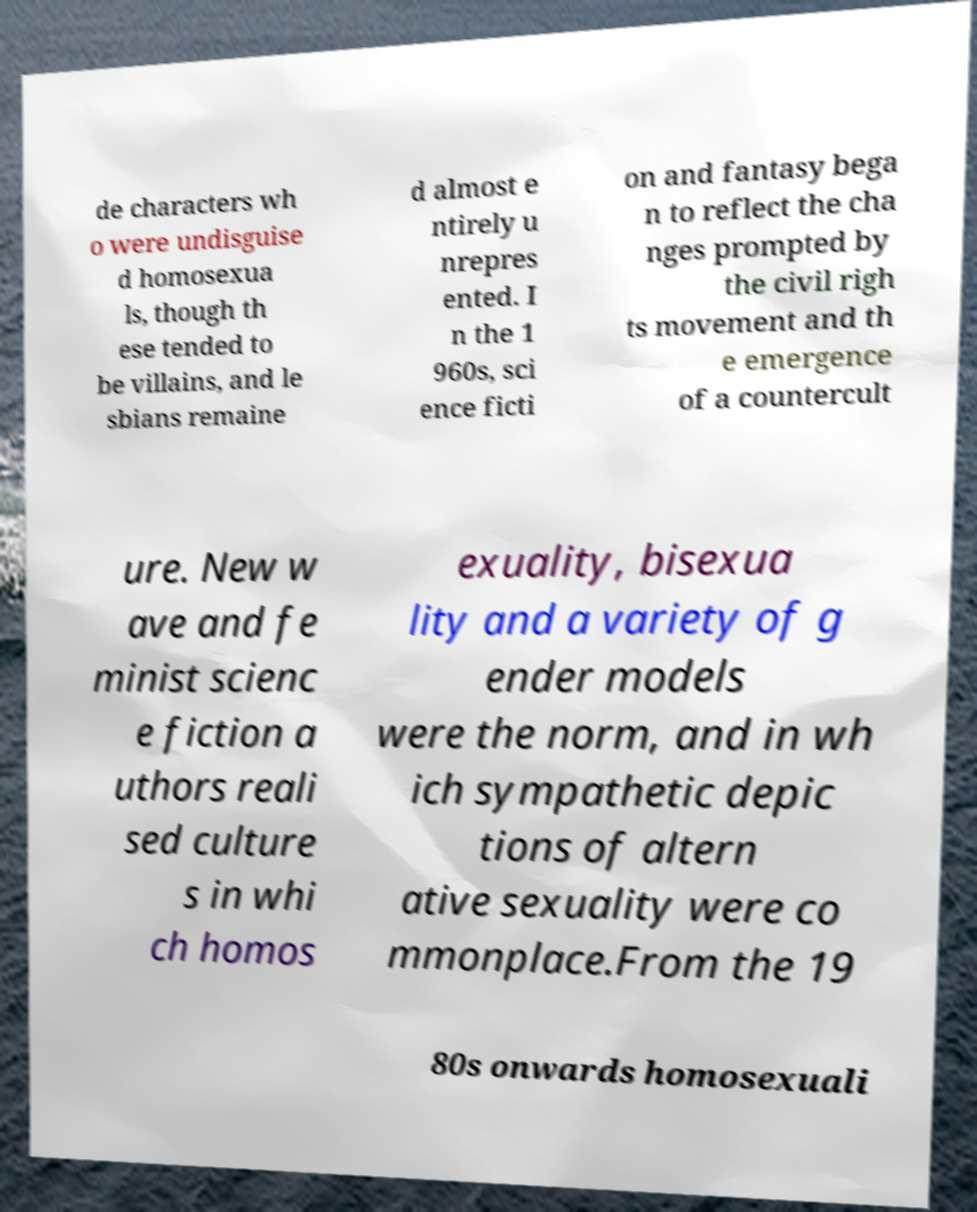Please read and relay the text visible in this image. What does it say? de characters wh o were undisguise d homosexua ls, though th ese tended to be villains, and le sbians remaine d almost e ntirely u nrepres ented. I n the 1 960s, sci ence ficti on and fantasy bega n to reflect the cha nges prompted by the civil righ ts movement and th e emergence of a countercult ure. New w ave and fe minist scienc e fiction a uthors reali sed culture s in whi ch homos exuality, bisexua lity and a variety of g ender models were the norm, and in wh ich sympathetic depic tions of altern ative sexuality were co mmonplace.From the 19 80s onwards homosexuali 